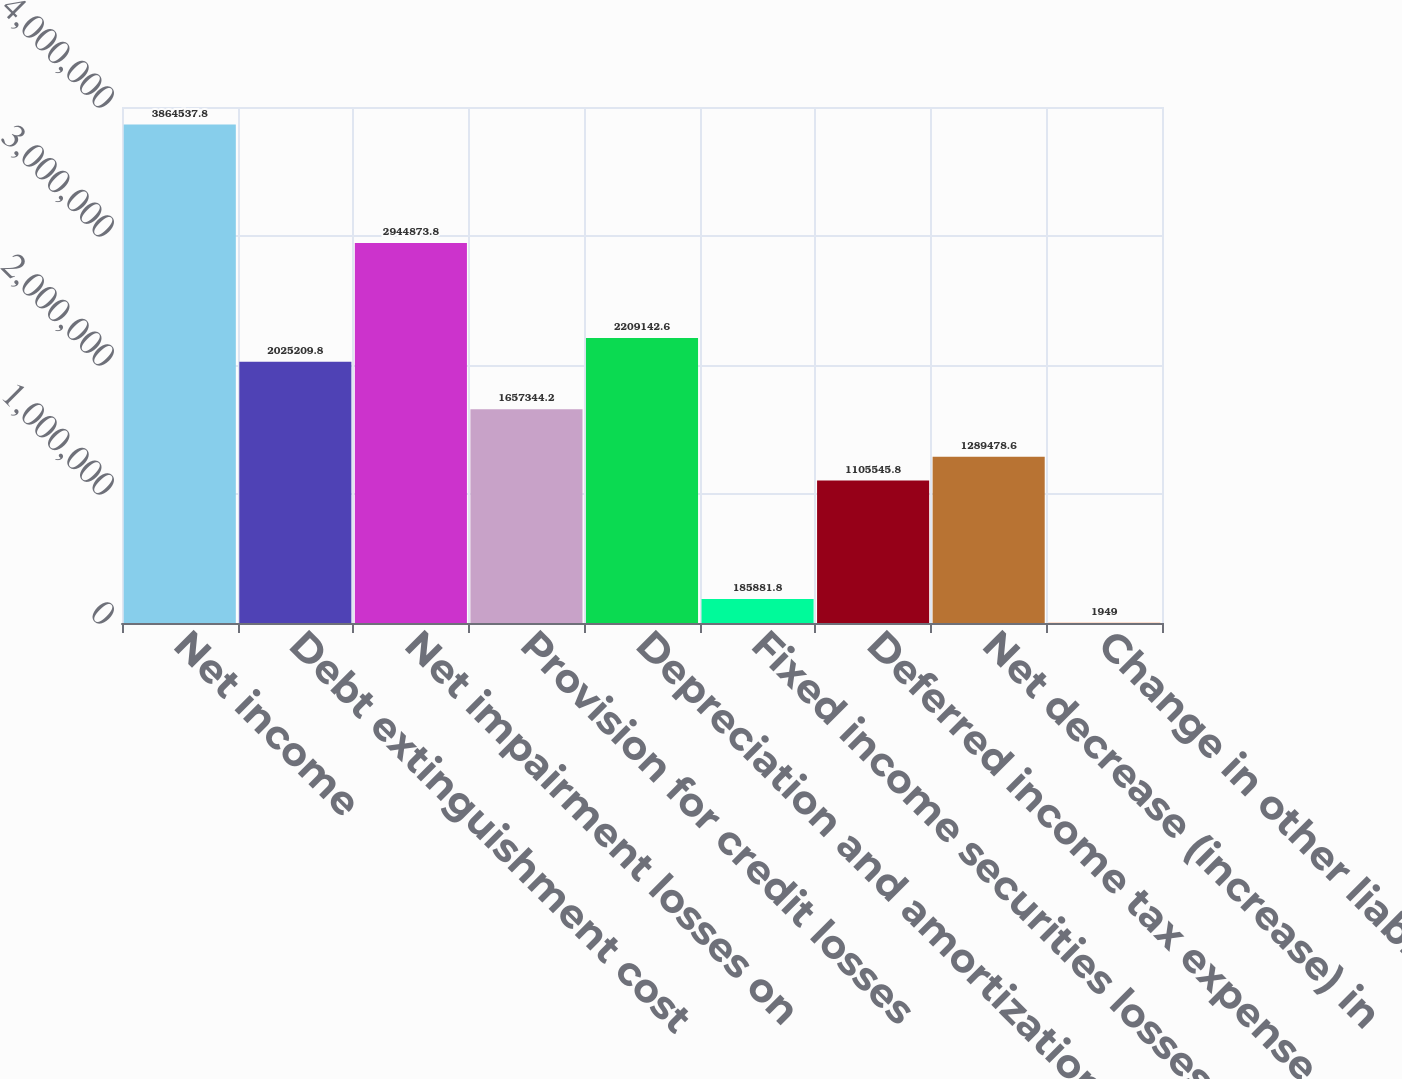<chart> <loc_0><loc_0><loc_500><loc_500><bar_chart><fcel>Net income<fcel>Debt extinguishment cost<fcel>Net impairment losses on<fcel>Provision for credit losses<fcel>Depreciation and amortization<fcel>Fixed income securities losses<fcel>Deferred income tax expense<fcel>Net decrease (increase) in<fcel>Change in other liabilities<nl><fcel>3.86454e+06<fcel>2.02521e+06<fcel>2.94487e+06<fcel>1.65734e+06<fcel>2.20914e+06<fcel>185882<fcel>1.10555e+06<fcel>1.28948e+06<fcel>1949<nl></chart> 